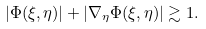<formula> <loc_0><loc_0><loc_500><loc_500>| \Phi ( \xi , \eta ) | + | \nabla _ { \eta } \Phi ( \xi , \eta ) | \gtrsim 1 .</formula> 